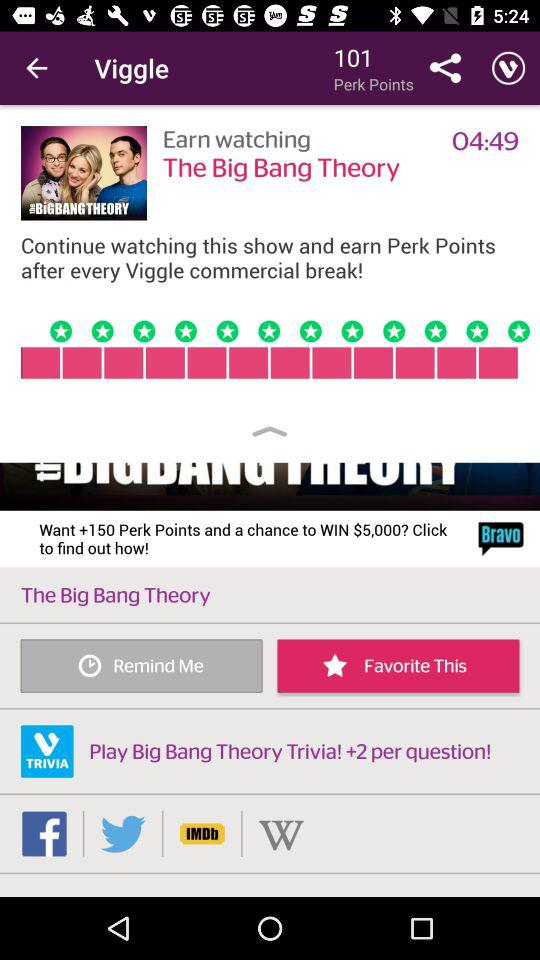What is the application name? The application name is "Viggle". 